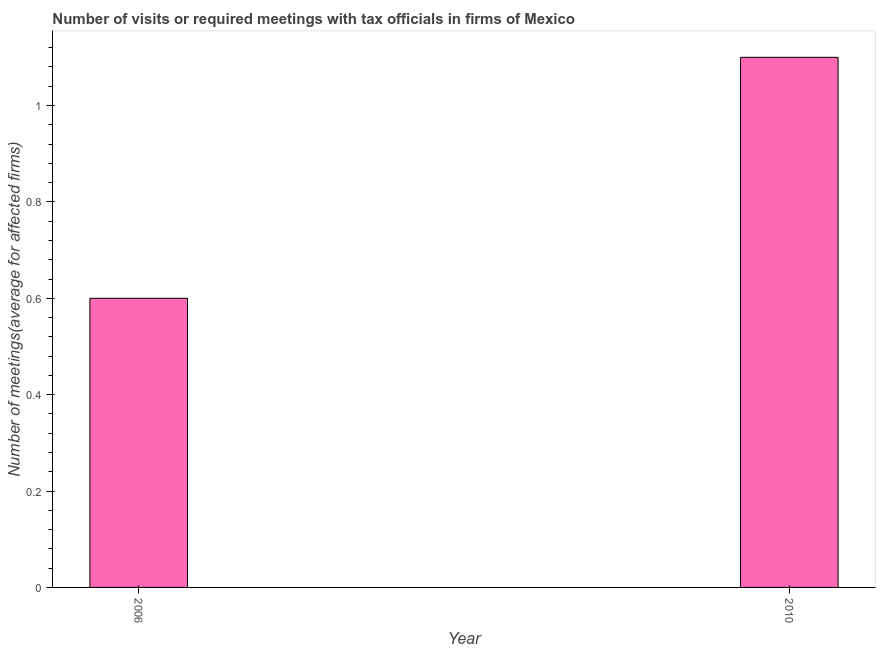Does the graph contain any zero values?
Offer a terse response. No. What is the title of the graph?
Offer a terse response. Number of visits or required meetings with tax officials in firms of Mexico. What is the label or title of the Y-axis?
Your answer should be very brief. Number of meetings(average for affected firms). What is the number of required meetings with tax officials in 2006?
Your answer should be very brief. 0.6. Across all years, what is the minimum number of required meetings with tax officials?
Provide a short and direct response. 0.6. In which year was the number of required meetings with tax officials maximum?
Ensure brevity in your answer.  2010. In which year was the number of required meetings with tax officials minimum?
Offer a very short reply. 2006. What is the sum of the number of required meetings with tax officials?
Your answer should be compact. 1.7. What is the average number of required meetings with tax officials per year?
Provide a succinct answer. 0.85. What is the median number of required meetings with tax officials?
Offer a very short reply. 0.85. In how many years, is the number of required meetings with tax officials greater than 1.08 ?
Your response must be concise. 1. Do a majority of the years between 2006 and 2010 (inclusive) have number of required meetings with tax officials greater than 0.2 ?
Give a very brief answer. Yes. What is the ratio of the number of required meetings with tax officials in 2006 to that in 2010?
Your response must be concise. 0.55. How many years are there in the graph?
Provide a short and direct response. 2. Are the values on the major ticks of Y-axis written in scientific E-notation?
Ensure brevity in your answer.  No. What is the Number of meetings(average for affected firms) of 2010?
Keep it short and to the point. 1.1. What is the ratio of the Number of meetings(average for affected firms) in 2006 to that in 2010?
Keep it short and to the point. 0.55. 